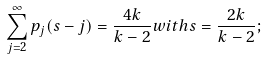<formula> <loc_0><loc_0><loc_500><loc_500>\sum _ { j = 2 } ^ { \infty } p _ { j } ( s - j ) = \frac { 4 k } { k - 2 } w i t h s = \frac { 2 k } { k - 2 } ;</formula> 